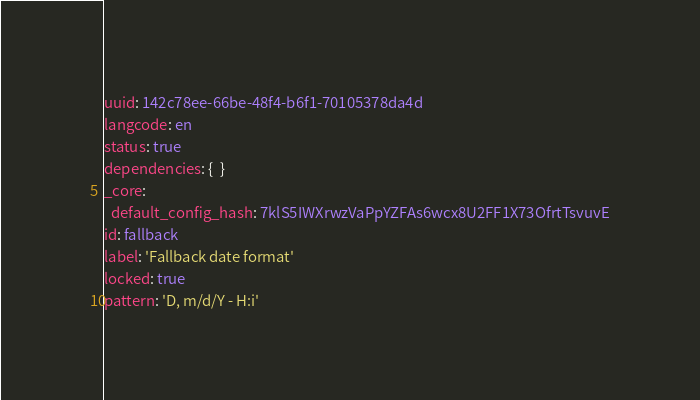Convert code to text. <code><loc_0><loc_0><loc_500><loc_500><_YAML_>uuid: 142c78ee-66be-48f4-b6f1-70105378da4d
langcode: en
status: true
dependencies: {  }
_core:
  default_config_hash: 7klS5IWXrwzVaPpYZFAs6wcx8U2FF1X73OfrtTsvuvE
id: fallback
label: 'Fallback date format'
locked: true
pattern: 'D, m/d/Y - H:i'
</code> 